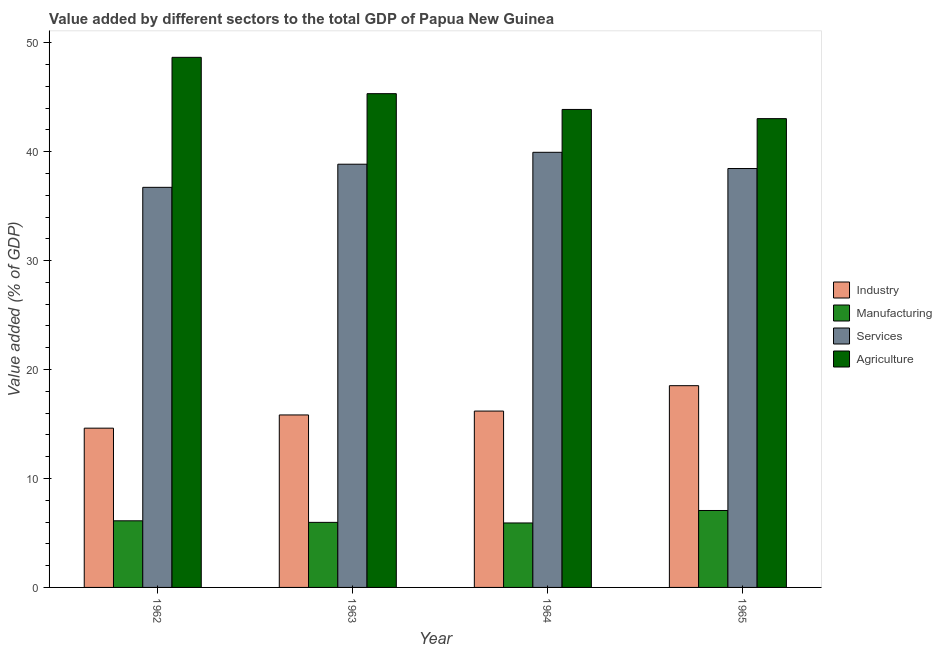Are the number of bars on each tick of the X-axis equal?
Your answer should be very brief. Yes. How many bars are there on the 2nd tick from the right?
Make the answer very short. 4. What is the label of the 4th group of bars from the left?
Your answer should be very brief. 1965. In how many cases, is the number of bars for a given year not equal to the number of legend labels?
Provide a short and direct response. 0. What is the value added by manufacturing sector in 1964?
Offer a very short reply. 5.92. Across all years, what is the maximum value added by agricultural sector?
Offer a terse response. 48.66. Across all years, what is the minimum value added by manufacturing sector?
Make the answer very short. 5.92. In which year was the value added by manufacturing sector maximum?
Give a very brief answer. 1965. In which year was the value added by services sector minimum?
Give a very brief answer. 1962. What is the total value added by services sector in the graph?
Provide a succinct answer. 153.96. What is the difference between the value added by agricultural sector in 1962 and that in 1963?
Provide a short and direct response. 3.34. What is the difference between the value added by services sector in 1962 and the value added by industrial sector in 1963?
Give a very brief answer. -2.12. What is the average value added by agricultural sector per year?
Provide a succinct answer. 45.22. In how many years, is the value added by agricultural sector greater than 38 %?
Make the answer very short. 4. What is the ratio of the value added by industrial sector in 1962 to that in 1963?
Your response must be concise. 0.92. What is the difference between the highest and the second highest value added by services sector?
Your answer should be very brief. 1.09. What is the difference between the highest and the lowest value added by industrial sector?
Offer a very short reply. 3.9. In how many years, is the value added by agricultural sector greater than the average value added by agricultural sector taken over all years?
Offer a terse response. 2. What does the 4th bar from the left in 1965 represents?
Offer a very short reply. Agriculture. What does the 2nd bar from the right in 1963 represents?
Keep it short and to the point. Services. Is it the case that in every year, the sum of the value added by industrial sector and value added by manufacturing sector is greater than the value added by services sector?
Offer a very short reply. No. How many years are there in the graph?
Make the answer very short. 4. Where does the legend appear in the graph?
Keep it short and to the point. Center right. What is the title of the graph?
Your answer should be compact. Value added by different sectors to the total GDP of Papua New Guinea. What is the label or title of the X-axis?
Your response must be concise. Year. What is the label or title of the Y-axis?
Give a very brief answer. Value added (% of GDP). What is the Value added (% of GDP) of Industry in 1962?
Provide a short and direct response. 14.62. What is the Value added (% of GDP) of Manufacturing in 1962?
Your answer should be very brief. 6.11. What is the Value added (% of GDP) in Services in 1962?
Your answer should be compact. 36.72. What is the Value added (% of GDP) of Agriculture in 1962?
Your answer should be compact. 48.66. What is the Value added (% of GDP) of Industry in 1963?
Ensure brevity in your answer.  15.83. What is the Value added (% of GDP) in Manufacturing in 1963?
Ensure brevity in your answer.  5.97. What is the Value added (% of GDP) in Services in 1963?
Your answer should be compact. 38.85. What is the Value added (% of GDP) of Agriculture in 1963?
Make the answer very short. 45.32. What is the Value added (% of GDP) in Industry in 1964?
Offer a terse response. 16.19. What is the Value added (% of GDP) of Manufacturing in 1964?
Offer a very short reply. 5.92. What is the Value added (% of GDP) in Services in 1964?
Keep it short and to the point. 39.94. What is the Value added (% of GDP) in Agriculture in 1964?
Keep it short and to the point. 43.87. What is the Value added (% of GDP) in Industry in 1965?
Offer a very short reply. 18.52. What is the Value added (% of GDP) in Manufacturing in 1965?
Provide a succinct answer. 7.06. What is the Value added (% of GDP) in Services in 1965?
Offer a terse response. 38.45. What is the Value added (% of GDP) in Agriculture in 1965?
Offer a terse response. 43.03. Across all years, what is the maximum Value added (% of GDP) in Industry?
Offer a very short reply. 18.52. Across all years, what is the maximum Value added (% of GDP) in Manufacturing?
Give a very brief answer. 7.06. Across all years, what is the maximum Value added (% of GDP) of Services?
Keep it short and to the point. 39.94. Across all years, what is the maximum Value added (% of GDP) of Agriculture?
Give a very brief answer. 48.66. Across all years, what is the minimum Value added (% of GDP) of Industry?
Give a very brief answer. 14.62. Across all years, what is the minimum Value added (% of GDP) in Manufacturing?
Your answer should be very brief. 5.92. Across all years, what is the minimum Value added (% of GDP) in Services?
Ensure brevity in your answer.  36.72. Across all years, what is the minimum Value added (% of GDP) of Agriculture?
Offer a very short reply. 43.03. What is the total Value added (% of GDP) of Industry in the graph?
Offer a terse response. 65.16. What is the total Value added (% of GDP) of Manufacturing in the graph?
Give a very brief answer. 25.06. What is the total Value added (% of GDP) in Services in the graph?
Your answer should be compact. 153.96. What is the total Value added (% of GDP) of Agriculture in the graph?
Make the answer very short. 180.88. What is the difference between the Value added (% of GDP) of Industry in 1962 and that in 1963?
Your answer should be compact. -1.21. What is the difference between the Value added (% of GDP) of Manufacturing in 1962 and that in 1963?
Provide a short and direct response. 0.14. What is the difference between the Value added (% of GDP) of Services in 1962 and that in 1963?
Keep it short and to the point. -2.12. What is the difference between the Value added (% of GDP) of Agriculture in 1962 and that in 1963?
Give a very brief answer. 3.34. What is the difference between the Value added (% of GDP) of Industry in 1962 and that in 1964?
Offer a very short reply. -1.57. What is the difference between the Value added (% of GDP) in Manufacturing in 1962 and that in 1964?
Ensure brevity in your answer.  0.2. What is the difference between the Value added (% of GDP) of Services in 1962 and that in 1964?
Your response must be concise. -3.22. What is the difference between the Value added (% of GDP) of Agriculture in 1962 and that in 1964?
Give a very brief answer. 4.78. What is the difference between the Value added (% of GDP) in Industry in 1962 and that in 1965?
Your answer should be very brief. -3.9. What is the difference between the Value added (% of GDP) of Manufacturing in 1962 and that in 1965?
Provide a short and direct response. -0.95. What is the difference between the Value added (% of GDP) of Services in 1962 and that in 1965?
Your answer should be compact. -1.73. What is the difference between the Value added (% of GDP) in Agriculture in 1962 and that in 1965?
Your response must be concise. 5.63. What is the difference between the Value added (% of GDP) of Industry in 1963 and that in 1964?
Offer a very short reply. -0.36. What is the difference between the Value added (% of GDP) of Manufacturing in 1963 and that in 1964?
Provide a short and direct response. 0.05. What is the difference between the Value added (% of GDP) in Services in 1963 and that in 1964?
Your answer should be compact. -1.09. What is the difference between the Value added (% of GDP) of Agriculture in 1963 and that in 1964?
Your response must be concise. 1.45. What is the difference between the Value added (% of GDP) in Industry in 1963 and that in 1965?
Your answer should be compact. -2.69. What is the difference between the Value added (% of GDP) in Manufacturing in 1963 and that in 1965?
Your response must be concise. -1.09. What is the difference between the Value added (% of GDP) in Services in 1963 and that in 1965?
Ensure brevity in your answer.  0.4. What is the difference between the Value added (% of GDP) in Agriculture in 1963 and that in 1965?
Your answer should be very brief. 2.29. What is the difference between the Value added (% of GDP) in Industry in 1964 and that in 1965?
Make the answer very short. -2.33. What is the difference between the Value added (% of GDP) in Manufacturing in 1964 and that in 1965?
Ensure brevity in your answer.  -1.14. What is the difference between the Value added (% of GDP) of Services in 1964 and that in 1965?
Offer a terse response. 1.49. What is the difference between the Value added (% of GDP) of Agriculture in 1964 and that in 1965?
Make the answer very short. 0.84. What is the difference between the Value added (% of GDP) in Industry in 1962 and the Value added (% of GDP) in Manufacturing in 1963?
Offer a very short reply. 8.65. What is the difference between the Value added (% of GDP) in Industry in 1962 and the Value added (% of GDP) in Services in 1963?
Provide a short and direct response. -24.23. What is the difference between the Value added (% of GDP) in Industry in 1962 and the Value added (% of GDP) in Agriculture in 1963?
Ensure brevity in your answer.  -30.7. What is the difference between the Value added (% of GDP) in Manufacturing in 1962 and the Value added (% of GDP) in Services in 1963?
Ensure brevity in your answer.  -32.73. What is the difference between the Value added (% of GDP) of Manufacturing in 1962 and the Value added (% of GDP) of Agriculture in 1963?
Provide a succinct answer. -39.21. What is the difference between the Value added (% of GDP) of Services in 1962 and the Value added (% of GDP) of Agriculture in 1963?
Offer a very short reply. -8.6. What is the difference between the Value added (% of GDP) of Industry in 1962 and the Value added (% of GDP) of Manufacturing in 1964?
Make the answer very short. 8.7. What is the difference between the Value added (% of GDP) in Industry in 1962 and the Value added (% of GDP) in Services in 1964?
Ensure brevity in your answer.  -25.32. What is the difference between the Value added (% of GDP) in Industry in 1962 and the Value added (% of GDP) in Agriculture in 1964?
Ensure brevity in your answer.  -29.25. What is the difference between the Value added (% of GDP) of Manufacturing in 1962 and the Value added (% of GDP) of Services in 1964?
Offer a very short reply. -33.82. What is the difference between the Value added (% of GDP) in Manufacturing in 1962 and the Value added (% of GDP) in Agriculture in 1964?
Give a very brief answer. -37.76. What is the difference between the Value added (% of GDP) in Services in 1962 and the Value added (% of GDP) in Agriculture in 1964?
Provide a succinct answer. -7.15. What is the difference between the Value added (% of GDP) of Industry in 1962 and the Value added (% of GDP) of Manufacturing in 1965?
Your answer should be compact. 7.56. What is the difference between the Value added (% of GDP) of Industry in 1962 and the Value added (% of GDP) of Services in 1965?
Make the answer very short. -23.83. What is the difference between the Value added (% of GDP) in Industry in 1962 and the Value added (% of GDP) in Agriculture in 1965?
Keep it short and to the point. -28.41. What is the difference between the Value added (% of GDP) of Manufacturing in 1962 and the Value added (% of GDP) of Services in 1965?
Offer a very short reply. -32.34. What is the difference between the Value added (% of GDP) of Manufacturing in 1962 and the Value added (% of GDP) of Agriculture in 1965?
Provide a short and direct response. -36.92. What is the difference between the Value added (% of GDP) in Services in 1962 and the Value added (% of GDP) in Agriculture in 1965?
Your answer should be very brief. -6.31. What is the difference between the Value added (% of GDP) in Industry in 1963 and the Value added (% of GDP) in Manufacturing in 1964?
Give a very brief answer. 9.91. What is the difference between the Value added (% of GDP) of Industry in 1963 and the Value added (% of GDP) of Services in 1964?
Your response must be concise. -24.11. What is the difference between the Value added (% of GDP) of Industry in 1963 and the Value added (% of GDP) of Agriculture in 1964?
Provide a succinct answer. -28.04. What is the difference between the Value added (% of GDP) of Manufacturing in 1963 and the Value added (% of GDP) of Services in 1964?
Give a very brief answer. -33.97. What is the difference between the Value added (% of GDP) in Manufacturing in 1963 and the Value added (% of GDP) in Agriculture in 1964?
Ensure brevity in your answer.  -37.9. What is the difference between the Value added (% of GDP) of Services in 1963 and the Value added (% of GDP) of Agriculture in 1964?
Provide a succinct answer. -5.03. What is the difference between the Value added (% of GDP) in Industry in 1963 and the Value added (% of GDP) in Manufacturing in 1965?
Ensure brevity in your answer.  8.77. What is the difference between the Value added (% of GDP) in Industry in 1963 and the Value added (% of GDP) in Services in 1965?
Offer a terse response. -22.62. What is the difference between the Value added (% of GDP) of Industry in 1963 and the Value added (% of GDP) of Agriculture in 1965?
Your answer should be very brief. -27.2. What is the difference between the Value added (% of GDP) in Manufacturing in 1963 and the Value added (% of GDP) in Services in 1965?
Provide a short and direct response. -32.48. What is the difference between the Value added (% of GDP) of Manufacturing in 1963 and the Value added (% of GDP) of Agriculture in 1965?
Provide a short and direct response. -37.06. What is the difference between the Value added (% of GDP) in Services in 1963 and the Value added (% of GDP) in Agriculture in 1965?
Your answer should be compact. -4.18. What is the difference between the Value added (% of GDP) of Industry in 1964 and the Value added (% of GDP) of Manufacturing in 1965?
Make the answer very short. 9.13. What is the difference between the Value added (% of GDP) of Industry in 1964 and the Value added (% of GDP) of Services in 1965?
Give a very brief answer. -22.26. What is the difference between the Value added (% of GDP) of Industry in 1964 and the Value added (% of GDP) of Agriculture in 1965?
Offer a very short reply. -26.84. What is the difference between the Value added (% of GDP) of Manufacturing in 1964 and the Value added (% of GDP) of Services in 1965?
Your answer should be very brief. -32.53. What is the difference between the Value added (% of GDP) in Manufacturing in 1964 and the Value added (% of GDP) in Agriculture in 1965?
Make the answer very short. -37.11. What is the difference between the Value added (% of GDP) in Services in 1964 and the Value added (% of GDP) in Agriculture in 1965?
Keep it short and to the point. -3.09. What is the average Value added (% of GDP) of Industry per year?
Keep it short and to the point. 16.29. What is the average Value added (% of GDP) in Manufacturing per year?
Make the answer very short. 6.27. What is the average Value added (% of GDP) of Services per year?
Offer a very short reply. 38.49. What is the average Value added (% of GDP) in Agriculture per year?
Make the answer very short. 45.22. In the year 1962, what is the difference between the Value added (% of GDP) of Industry and Value added (% of GDP) of Manufacturing?
Your answer should be very brief. 8.5. In the year 1962, what is the difference between the Value added (% of GDP) in Industry and Value added (% of GDP) in Services?
Keep it short and to the point. -22.1. In the year 1962, what is the difference between the Value added (% of GDP) in Industry and Value added (% of GDP) in Agriculture?
Your answer should be compact. -34.04. In the year 1962, what is the difference between the Value added (% of GDP) of Manufacturing and Value added (% of GDP) of Services?
Provide a short and direct response. -30.61. In the year 1962, what is the difference between the Value added (% of GDP) of Manufacturing and Value added (% of GDP) of Agriculture?
Offer a very short reply. -42.54. In the year 1962, what is the difference between the Value added (% of GDP) in Services and Value added (% of GDP) in Agriculture?
Your response must be concise. -11.93. In the year 1963, what is the difference between the Value added (% of GDP) of Industry and Value added (% of GDP) of Manufacturing?
Provide a succinct answer. 9.86. In the year 1963, what is the difference between the Value added (% of GDP) of Industry and Value added (% of GDP) of Services?
Your response must be concise. -23.02. In the year 1963, what is the difference between the Value added (% of GDP) of Industry and Value added (% of GDP) of Agriculture?
Offer a terse response. -29.49. In the year 1963, what is the difference between the Value added (% of GDP) in Manufacturing and Value added (% of GDP) in Services?
Provide a succinct answer. -32.88. In the year 1963, what is the difference between the Value added (% of GDP) of Manufacturing and Value added (% of GDP) of Agriculture?
Make the answer very short. -39.35. In the year 1963, what is the difference between the Value added (% of GDP) in Services and Value added (% of GDP) in Agriculture?
Your response must be concise. -6.47. In the year 1964, what is the difference between the Value added (% of GDP) of Industry and Value added (% of GDP) of Manufacturing?
Your answer should be compact. 10.27. In the year 1964, what is the difference between the Value added (% of GDP) of Industry and Value added (% of GDP) of Services?
Your response must be concise. -23.75. In the year 1964, what is the difference between the Value added (% of GDP) of Industry and Value added (% of GDP) of Agriculture?
Make the answer very short. -27.69. In the year 1964, what is the difference between the Value added (% of GDP) of Manufacturing and Value added (% of GDP) of Services?
Provide a short and direct response. -34.02. In the year 1964, what is the difference between the Value added (% of GDP) in Manufacturing and Value added (% of GDP) in Agriculture?
Make the answer very short. -37.96. In the year 1964, what is the difference between the Value added (% of GDP) of Services and Value added (% of GDP) of Agriculture?
Your response must be concise. -3.93. In the year 1965, what is the difference between the Value added (% of GDP) of Industry and Value added (% of GDP) of Manufacturing?
Ensure brevity in your answer.  11.46. In the year 1965, what is the difference between the Value added (% of GDP) of Industry and Value added (% of GDP) of Services?
Offer a very short reply. -19.93. In the year 1965, what is the difference between the Value added (% of GDP) in Industry and Value added (% of GDP) in Agriculture?
Your answer should be very brief. -24.51. In the year 1965, what is the difference between the Value added (% of GDP) in Manufacturing and Value added (% of GDP) in Services?
Offer a terse response. -31.39. In the year 1965, what is the difference between the Value added (% of GDP) of Manufacturing and Value added (% of GDP) of Agriculture?
Your answer should be compact. -35.97. In the year 1965, what is the difference between the Value added (% of GDP) of Services and Value added (% of GDP) of Agriculture?
Offer a terse response. -4.58. What is the ratio of the Value added (% of GDP) in Industry in 1962 to that in 1963?
Your answer should be compact. 0.92. What is the ratio of the Value added (% of GDP) of Manufacturing in 1962 to that in 1963?
Your answer should be very brief. 1.02. What is the ratio of the Value added (% of GDP) of Services in 1962 to that in 1963?
Your response must be concise. 0.95. What is the ratio of the Value added (% of GDP) in Agriculture in 1962 to that in 1963?
Keep it short and to the point. 1.07. What is the ratio of the Value added (% of GDP) of Industry in 1962 to that in 1964?
Your answer should be compact. 0.9. What is the ratio of the Value added (% of GDP) in Services in 1962 to that in 1964?
Your response must be concise. 0.92. What is the ratio of the Value added (% of GDP) in Agriculture in 1962 to that in 1964?
Give a very brief answer. 1.11. What is the ratio of the Value added (% of GDP) of Industry in 1962 to that in 1965?
Keep it short and to the point. 0.79. What is the ratio of the Value added (% of GDP) in Manufacturing in 1962 to that in 1965?
Provide a short and direct response. 0.87. What is the ratio of the Value added (% of GDP) of Services in 1962 to that in 1965?
Your answer should be very brief. 0.96. What is the ratio of the Value added (% of GDP) in Agriculture in 1962 to that in 1965?
Your answer should be compact. 1.13. What is the ratio of the Value added (% of GDP) in Manufacturing in 1963 to that in 1964?
Keep it short and to the point. 1.01. What is the ratio of the Value added (% of GDP) of Services in 1963 to that in 1964?
Provide a succinct answer. 0.97. What is the ratio of the Value added (% of GDP) in Agriculture in 1963 to that in 1964?
Provide a short and direct response. 1.03. What is the ratio of the Value added (% of GDP) in Industry in 1963 to that in 1965?
Your answer should be very brief. 0.85. What is the ratio of the Value added (% of GDP) in Manufacturing in 1963 to that in 1965?
Give a very brief answer. 0.85. What is the ratio of the Value added (% of GDP) in Services in 1963 to that in 1965?
Provide a short and direct response. 1.01. What is the ratio of the Value added (% of GDP) of Agriculture in 1963 to that in 1965?
Offer a very short reply. 1.05. What is the ratio of the Value added (% of GDP) of Industry in 1964 to that in 1965?
Offer a terse response. 0.87. What is the ratio of the Value added (% of GDP) in Manufacturing in 1964 to that in 1965?
Your answer should be very brief. 0.84. What is the ratio of the Value added (% of GDP) of Services in 1964 to that in 1965?
Your answer should be compact. 1.04. What is the ratio of the Value added (% of GDP) in Agriculture in 1964 to that in 1965?
Ensure brevity in your answer.  1.02. What is the difference between the highest and the second highest Value added (% of GDP) in Industry?
Provide a succinct answer. 2.33. What is the difference between the highest and the second highest Value added (% of GDP) in Manufacturing?
Provide a succinct answer. 0.95. What is the difference between the highest and the second highest Value added (% of GDP) in Services?
Give a very brief answer. 1.09. What is the difference between the highest and the second highest Value added (% of GDP) in Agriculture?
Keep it short and to the point. 3.34. What is the difference between the highest and the lowest Value added (% of GDP) in Industry?
Offer a very short reply. 3.9. What is the difference between the highest and the lowest Value added (% of GDP) in Manufacturing?
Ensure brevity in your answer.  1.14. What is the difference between the highest and the lowest Value added (% of GDP) in Services?
Keep it short and to the point. 3.22. What is the difference between the highest and the lowest Value added (% of GDP) in Agriculture?
Offer a very short reply. 5.63. 